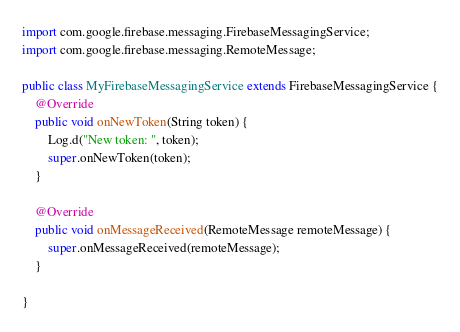<code> <loc_0><loc_0><loc_500><loc_500><_Java_>import com.google.firebase.messaging.FirebaseMessagingService;
import com.google.firebase.messaging.RemoteMessage;

public class MyFirebaseMessagingService extends FirebaseMessagingService {
    @Override
    public void onNewToken(String token) {
        Log.d("New token: ", token);
        super.onNewToken(token);
    }

    @Override
    public void onMessageReceived(RemoteMessage remoteMessage) {
        super.onMessageReceived(remoteMessage);
    }

}
</code> 